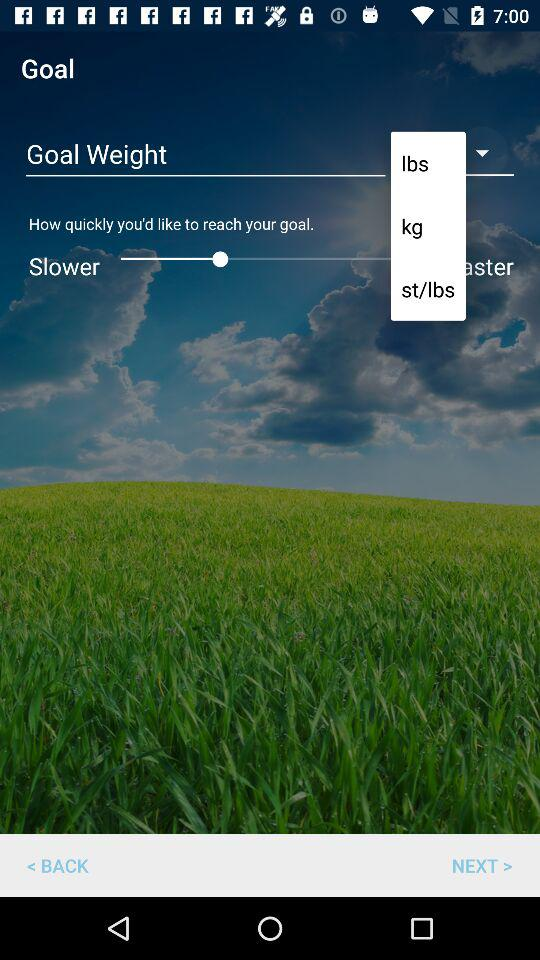How many units of weight are available for selection?
Answer the question using a single word or phrase. 3 